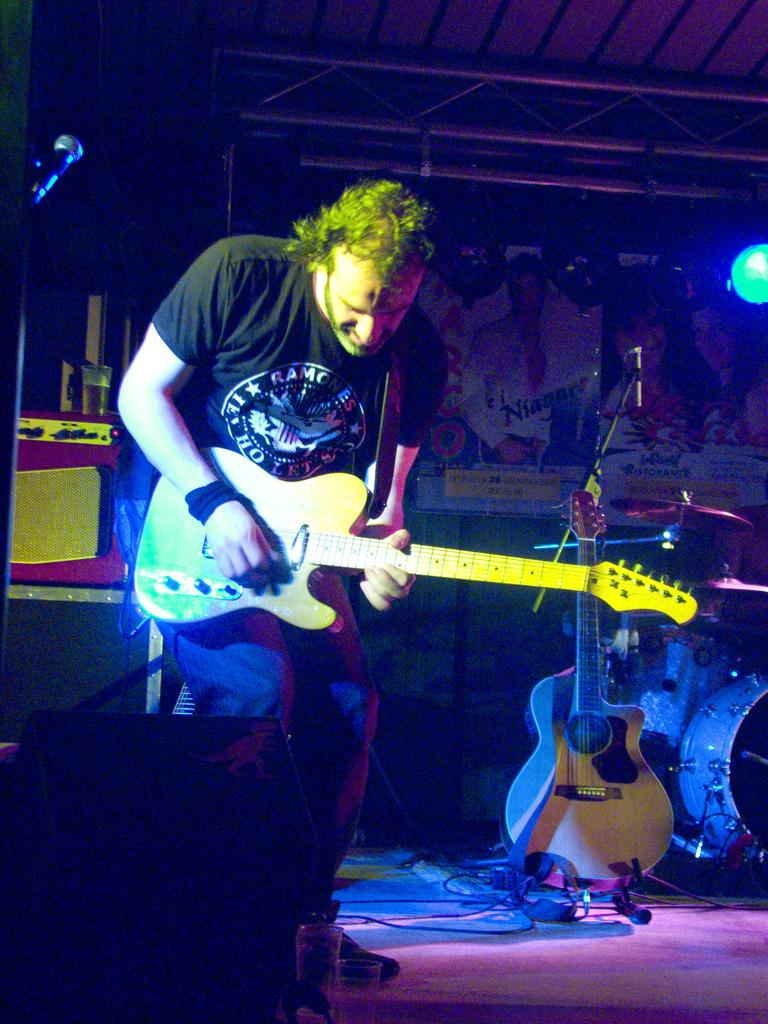Who is the main subject in the image? There is a man in the image. What is the man wearing? The man is wearing a black shirt. What is the man holding in the image? The man is holding a guitar. Can you describe any other details about the man's appearance? There is a black band tied on the man's right hand. What other musical instruments can be seen in the image? There are other musical instruments visible in the image. What type of trucks can be seen in the image? There are no trucks present in the image. Is the man in the image currently in jail? There is no indication in the image that the man is in jail. 